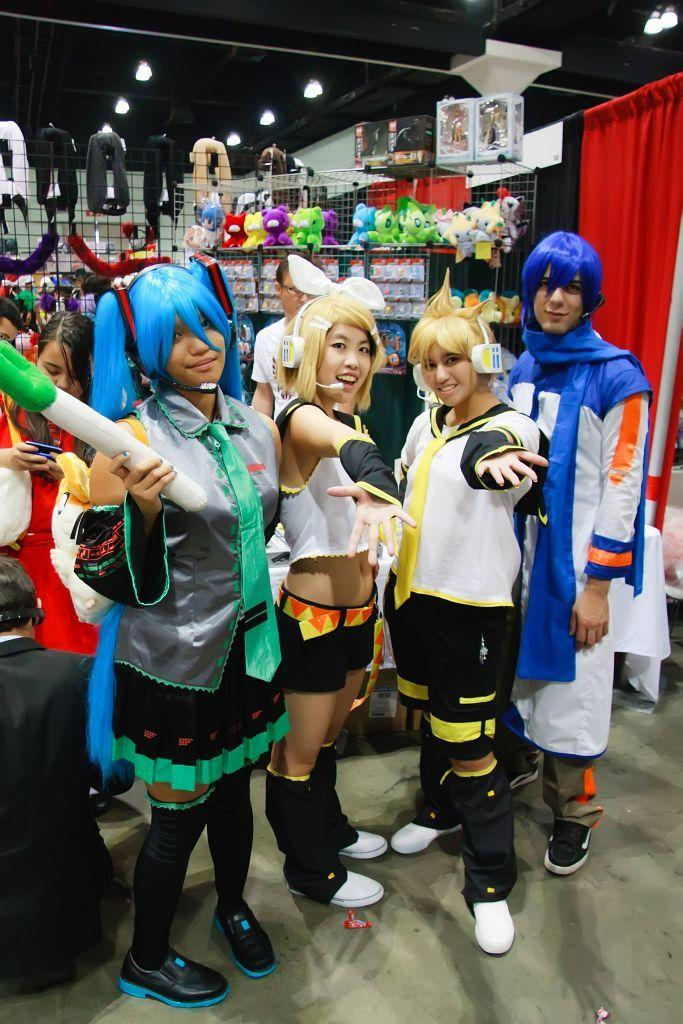What can be observed about the people in the image? There are people standing in the image, and they are wearing different costumes. What can be seen in the background of the image? Toys, lights, a red color cloth, and other objects are visible in the background. Can you describe the costumes the people are wearing? Unfortunately, the facts provided do not give specific details about the costumes. However, we can confirm that they are different from one another. How does the beef digest in the image? There is no beef present in the image, so it is not possible to determine how it would digest. 